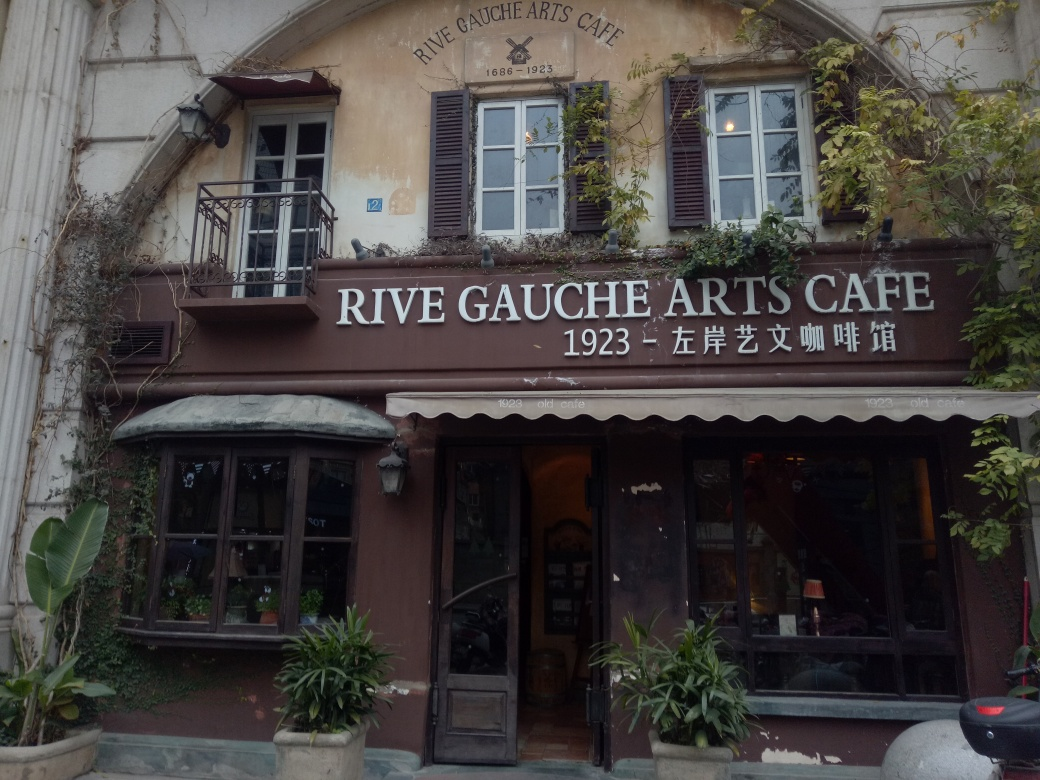What kind of clientele do you imagine frequents this café? Given its artistic branding and classic aesthetic, I imagine the Rive Gauche Arts Café attracts a clientele with an appreciation for the arts, history, and culture. Likely patrons could include local artists, writers, students, as well as tourists drawn to the café's charm and historical context. 